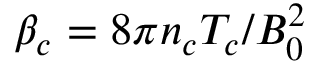Convert formula to latex. <formula><loc_0><loc_0><loc_500><loc_500>\beta _ { c } = 8 \pi n _ { c } T _ { c } / B _ { 0 } ^ { 2 }</formula> 